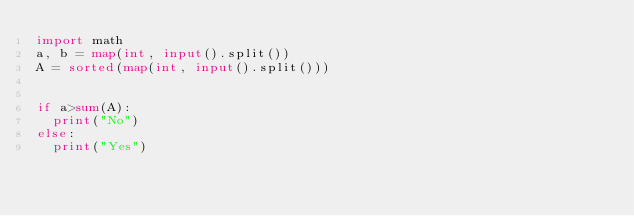Convert code to text. <code><loc_0><loc_0><loc_500><loc_500><_Python_>import math
a, b = map(int, input().split()) 
A = sorted(map(int, input().split())) 


if a>sum(A):
  print("No")
else:
  print("Yes")</code> 